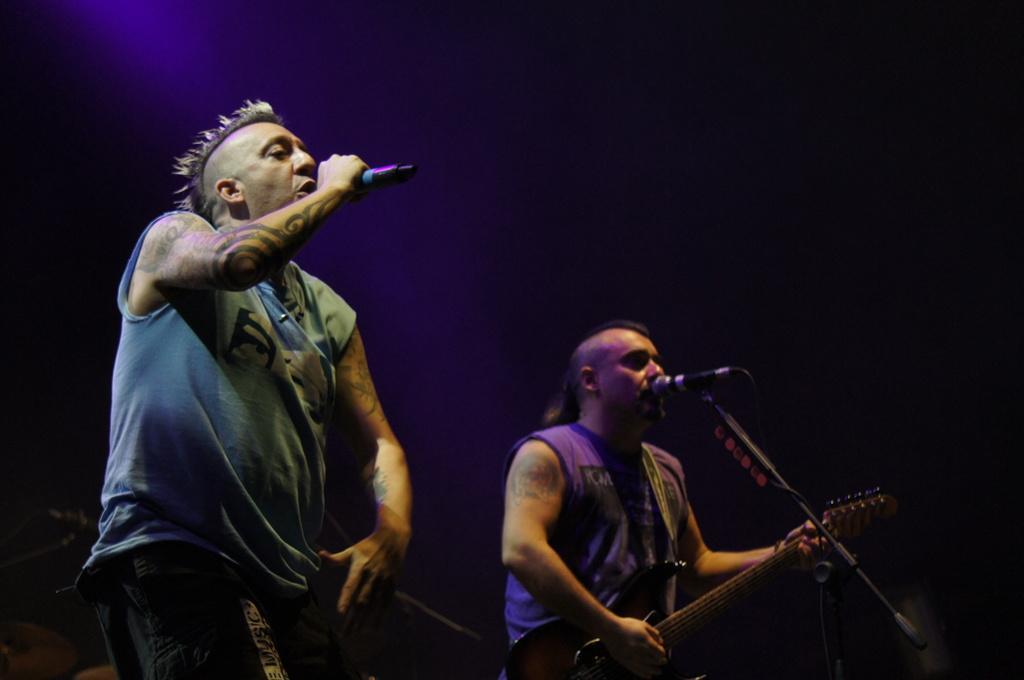Describe this image in one or two sentences. In this picture we have a man standing and singing a song in the microphone , another man standing and playing a guitar near the microphone. 